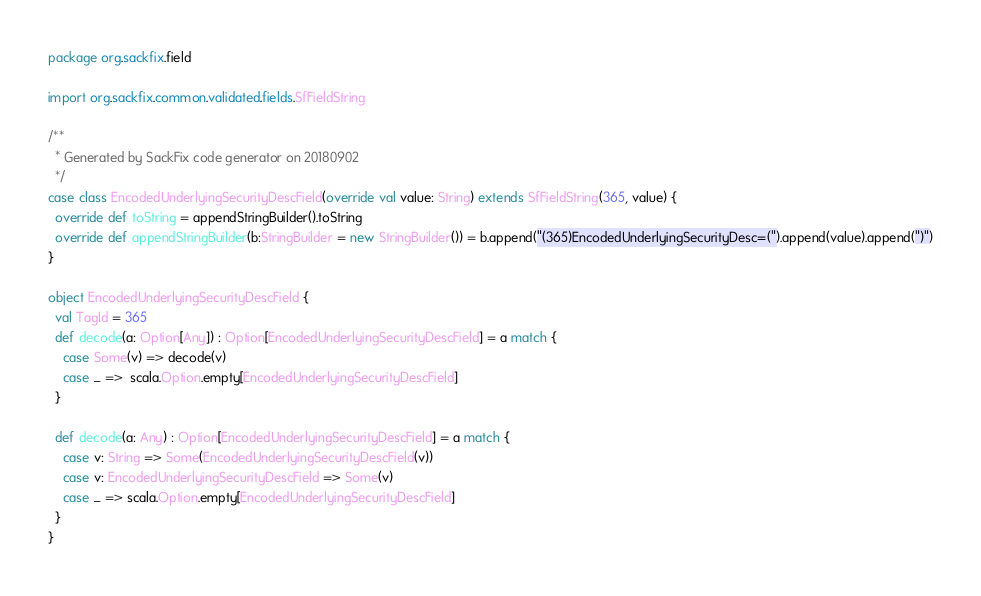Convert code to text. <code><loc_0><loc_0><loc_500><loc_500><_Scala_>package org.sackfix.field

import org.sackfix.common.validated.fields.SfFieldString

/**
  * Generated by SackFix code generator on 20180902
  */
case class EncodedUnderlyingSecurityDescField(override val value: String) extends SfFieldString(365, value) {
  override def toString = appendStringBuilder().toString
  override def appendStringBuilder(b:StringBuilder = new StringBuilder()) = b.append("(365)EncodedUnderlyingSecurityDesc=(").append(value).append(")")
}

object EncodedUnderlyingSecurityDescField {
  val TagId = 365  
  def decode(a: Option[Any]) : Option[EncodedUnderlyingSecurityDescField] = a match {
    case Some(v) => decode(v)
    case _ =>  scala.Option.empty[EncodedUnderlyingSecurityDescField]
  }

  def decode(a: Any) : Option[EncodedUnderlyingSecurityDescField] = a match {
    case v: String => Some(EncodedUnderlyingSecurityDescField(v))
    case v: EncodedUnderlyingSecurityDescField => Some(v)
    case _ => scala.Option.empty[EncodedUnderlyingSecurityDescField]
  } 
}
</code> 